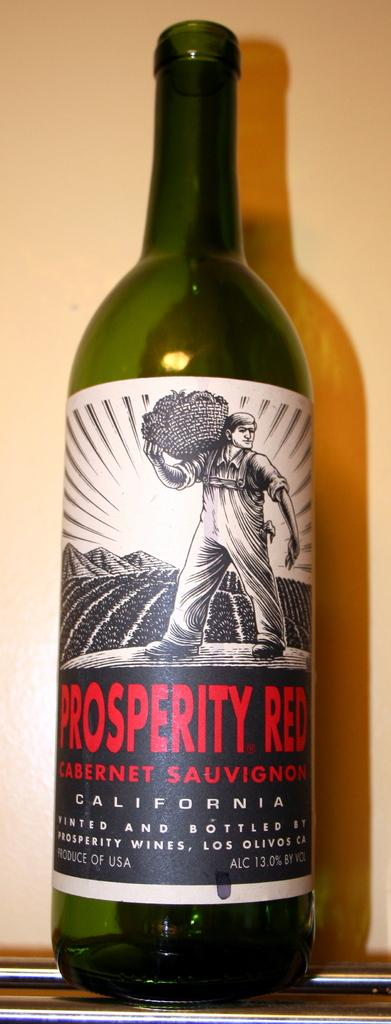What is the main object in the image? There is a wine bottle in the image. Is there anything on the wine bottle? Yes, the wine bottle has a sticker on it. What is depicted on the sticker? The sticker depicts a man holding a basket. What can be seen behind the wine bottle? The background of the image is a wall. What flavor of ice cream is being shaken in a circle in the image? There is no ice cream or any shaking motion in the image; it features a wine bottle with a sticker depicting a man holding a basket. 